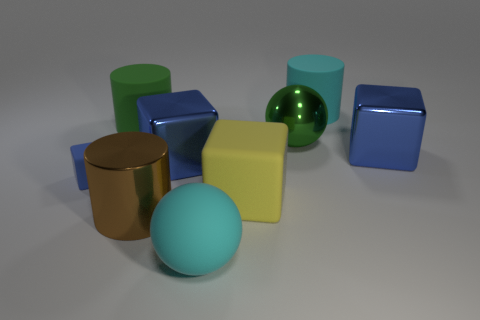Is there any other thing that has the same size as the blue matte object?
Offer a very short reply. No. Are there an equal number of shiny cylinders behind the shiny cylinder and large yellow matte cubes behind the yellow thing?
Keep it short and to the point. Yes. There is a ball behind the small blue object; what material is it?
Keep it short and to the point. Metal. What number of things are either blue matte things that are left of the large brown shiny cylinder or cyan matte balls?
Offer a very short reply. 2. How many other things are the same shape as the large yellow object?
Ensure brevity in your answer.  3. Is the shape of the big blue object right of the large cyan cylinder the same as  the large yellow rubber thing?
Ensure brevity in your answer.  Yes. Are there any blue metallic blocks in front of the large cyan sphere?
Provide a succinct answer. No. What number of large things are yellow matte cubes or brown metallic things?
Provide a short and direct response. 2. Are the cyan cylinder and the big brown cylinder made of the same material?
Your answer should be very brief. No. Is there another shiny cube that has the same color as the tiny cube?
Your answer should be very brief. Yes. 